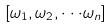Convert formula to latex. <formula><loc_0><loc_0><loc_500><loc_500>[ \omega _ { 1 } , \omega _ { 2 } , \cdot \cdot \cdot \omega _ { n } ]</formula> 